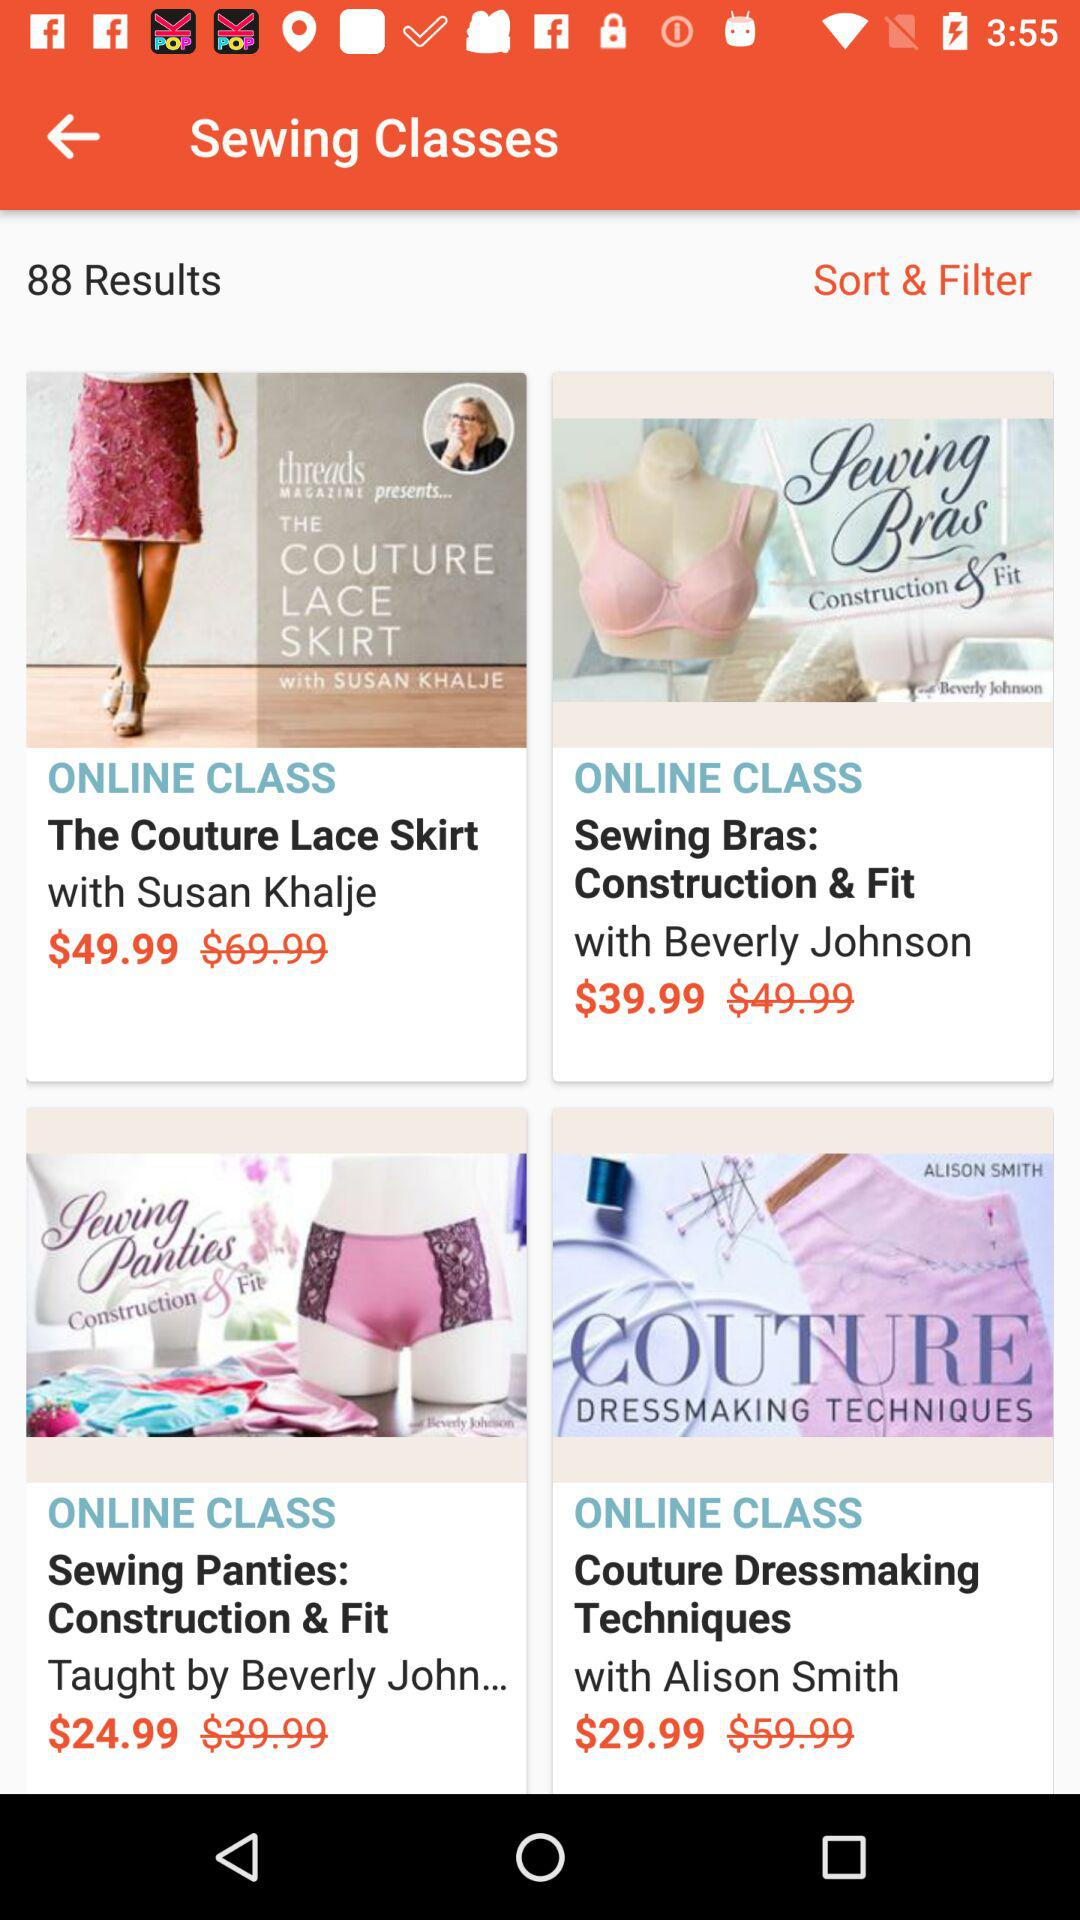What is the cost of sewing panties? The cost is $24.99. 